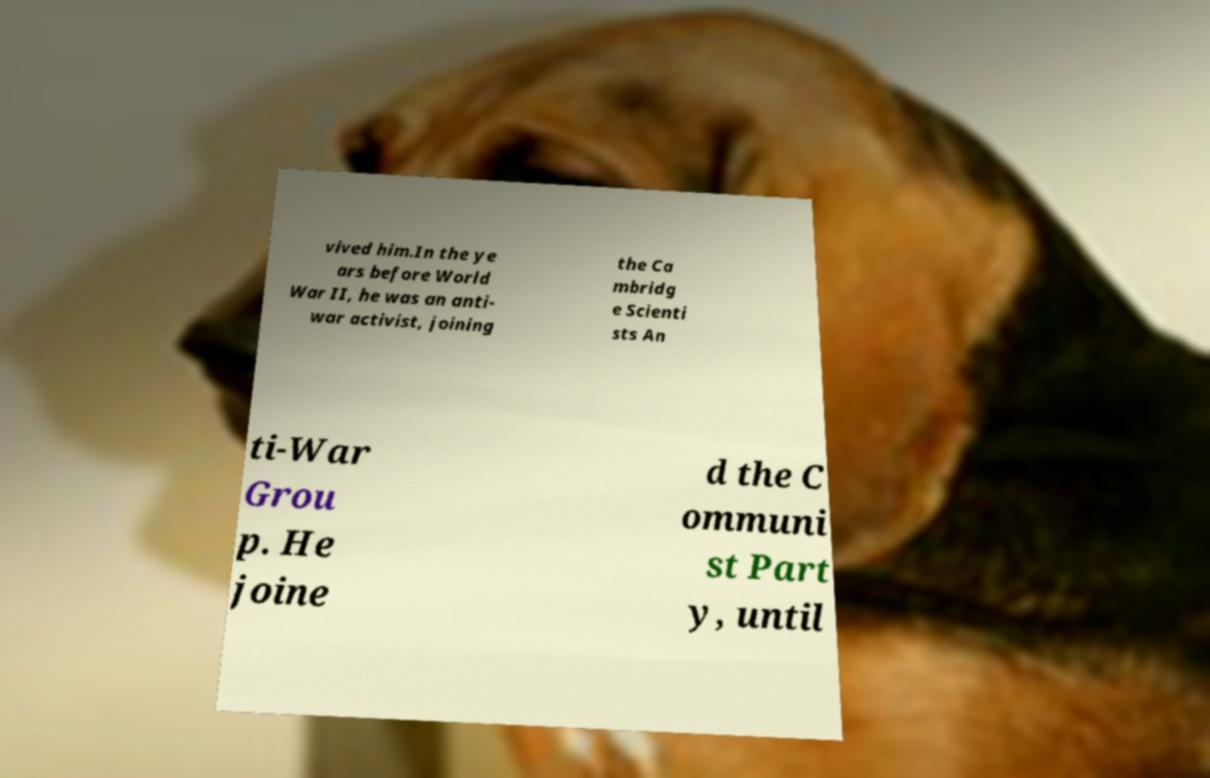There's text embedded in this image that I need extracted. Can you transcribe it verbatim? vived him.In the ye ars before World War II, he was an anti- war activist, joining the Ca mbridg e Scienti sts An ti-War Grou p. He joine d the C ommuni st Part y, until 